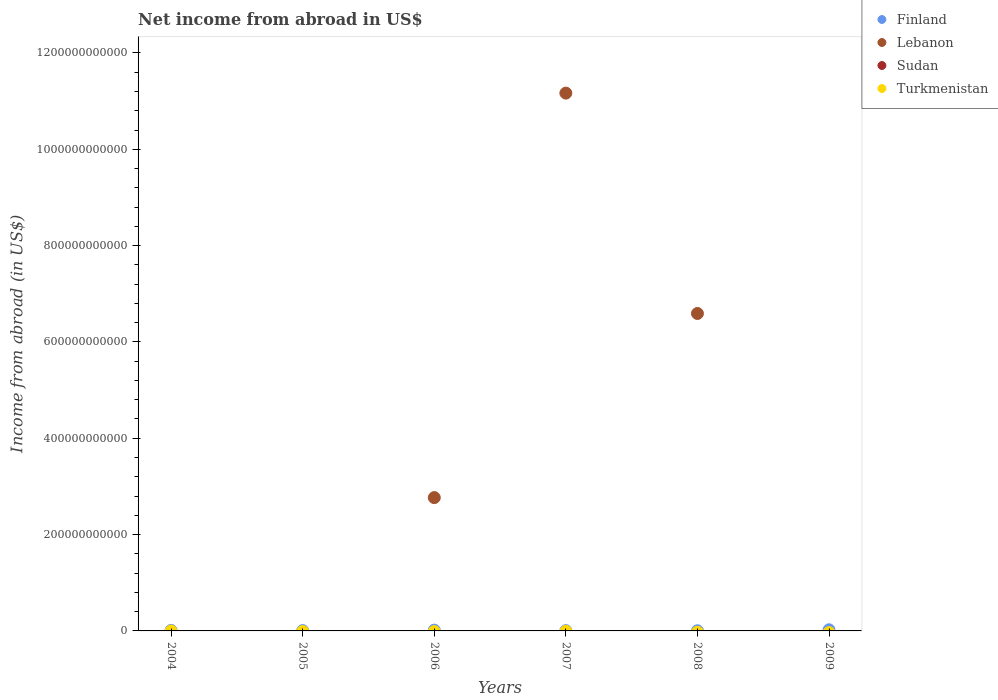Is the number of dotlines equal to the number of legend labels?
Give a very brief answer. No. What is the net income from abroad in Lebanon in 2007?
Offer a terse response. 1.12e+12. Across all years, what is the maximum net income from abroad in Lebanon?
Your answer should be very brief. 1.12e+12. What is the total net income from abroad in Finland in the graph?
Your answer should be compact. 6.70e+09. What is the difference between the net income from abroad in Finland in 2004 and that in 2007?
Offer a terse response. 5.26e+08. What is the average net income from abroad in Lebanon per year?
Ensure brevity in your answer.  3.42e+11. In how many years, is the net income from abroad in Turkmenistan greater than 400000000000 US$?
Provide a short and direct response. 0. Is the net income from abroad in Finland in 2004 less than that in 2007?
Your answer should be compact. No. What is the difference between the highest and the second highest net income from abroad in Lebanon?
Your answer should be very brief. 4.58e+11. What is the difference between the highest and the lowest net income from abroad in Lebanon?
Offer a very short reply. 1.12e+12. Is the sum of the net income from abroad in Finland in 2004 and 2005 greater than the maximum net income from abroad in Turkmenistan across all years?
Make the answer very short. Yes. Is it the case that in every year, the sum of the net income from abroad in Finland and net income from abroad in Sudan  is greater than the sum of net income from abroad in Lebanon and net income from abroad in Turkmenistan?
Your response must be concise. Yes. Is it the case that in every year, the sum of the net income from abroad in Finland and net income from abroad in Sudan  is greater than the net income from abroad in Lebanon?
Your answer should be compact. No. Does the net income from abroad in Finland monotonically increase over the years?
Make the answer very short. No. What is the difference between two consecutive major ticks on the Y-axis?
Offer a very short reply. 2.00e+11. Are the values on the major ticks of Y-axis written in scientific E-notation?
Your answer should be very brief. No. What is the title of the graph?
Give a very brief answer. Net income from abroad in US$. What is the label or title of the Y-axis?
Provide a short and direct response. Income from abroad (in US$). What is the Income from abroad (in US$) of Finland in 2004?
Keep it short and to the point. 1.12e+09. What is the Income from abroad (in US$) in Turkmenistan in 2004?
Your answer should be compact. 0. What is the Income from abroad (in US$) in Finland in 2005?
Offer a very short reply. 6.88e+08. What is the Income from abroad (in US$) of Lebanon in 2005?
Provide a short and direct response. 0. What is the Income from abroad (in US$) of Sudan in 2005?
Provide a succinct answer. 0. What is the Income from abroad (in US$) in Finland in 2006?
Offer a very short reply. 1.62e+09. What is the Income from abroad (in US$) of Lebanon in 2006?
Provide a succinct answer. 2.77e+11. What is the Income from abroad (in US$) of Turkmenistan in 2006?
Make the answer very short. 0. What is the Income from abroad (in US$) of Finland in 2007?
Your response must be concise. 5.89e+08. What is the Income from abroad (in US$) in Lebanon in 2007?
Offer a terse response. 1.12e+12. What is the Income from abroad (in US$) of Turkmenistan in 2007?
Provide a succinct answer. 0. What is the Income from abroad (in US$) in Finland in 2008?
Ensure brevity in your answer.  3.62e+08. What is the Income from abroad (in US$) of Lebanon in 2008?
Your response must be concise. 6.59e+11. What is the Income from abroad (in US$) of Turkmenistan in 2008?
Your answer should be very brief. 0. What is the Income from abroad (in US$) of Finland in 2009?
Offer a very short reply. 2.32e+09. Across all years, what is the maximum Income from abroad (in US$) of Finland?
Provide a succinct answer. 2.32e+09. Across all years, what is the maximum Income from abroad (in US$) of Lebanon?
Your response must be concise. 1.12e+12. Across all years, what is the minimum Income from abroad (in US$) of Finland?
Make the answer very short. 3.62e+08. What is the total Income from abroad (in US$) in Finland in the graph?
Your response must be concise. 6.70e+09. What is the total Income from abroad (in US$) of Lebanon in the graph?
Keep it short and to the point. 2.05e+12. What is the total Income from abroad (in US$) in Turkmenistan in the graph?
Keep it short and to the point. 0. What is the difference between the Income from abroad (in US$) of Finland in 2004 and that in 2005?
Provide a short and direct response. 4.27e+08. What is the difference between the Income from abroad (in US$) of Finland in 2004 and that in 2006?
Provide a succinct answer. -5.09e+08. What is the difference between the Income from abroad (in US$) in Finland in 2004 and that in 2007?
Your answer should be very brief. 5.26e+08. What is the difference between the Income from abroad (in US$) of Finland in 2004 and that in 2008?
Make the answer very short. 7.53e+08. What is the difference between the Income from abroad (in US$) in Finland in 2004 and that in 2009?
Your answer should be compact. -1.21e+09. What is the difference between the Income from abroad (in US$) in Finland in 2005 and that in 2006?
Make the answer very short. -9.36e+08. What is the difference between the Income from abroad (in US$) in Finland in 2005 and that in 2007?
Offer a terse response. 9.90e+07. What is the difference between the Income from abroad (in US$) in Finland in 2005 and that in 2008?
Give a very brief answer. 3.26e+08. What is the difference between the Income from abroad (in US$) of Finland in 2005 and that in 2009?
Your answer should be compact. -1.63e+09. What is the difference between the Income from abroad (in US$) of Finland in 2006 and that in 2007?
Provide a short and direct response. 1.04e+09. What is the difference between the Income from abroad (in US$) of Lebanon in 2006 and that in 2007?
Provide a succinct answer. -8.40e+11. What is the difference between the Income from abroad (in US$) in Finland in 2006 and that in 2008?
Offer a terse response. 1.26e+09. What is the difference between the Income from abroad (in US$) in Lebanon in 2006 and that in 2008?
Give a very brief answer. -3.82e+11. What is the difference between the Income from abroad (in US$) in Finland in 2006 and that in 2009?
Keep it short and to the point. -6.97e+08. What is the difference between the Income from abroad (in US$) in Finland in 2007 and that in 2008?
Ensure brevity in your answer.  2.27e+08. What is the difference between the Income from abroad (in US$) in Lebanon in 2007 and that in 2008?
Give a very brief answer. 4.58e+11. What is the difference between the Income from abroad (in US$) of Finland in 2007 and that in 2009?
Offer a terse response. -1.73e+09. What is the difference between the Income from abroad (in US$) of Finland in 2008 and that in 2009?
Provide a succinct answer. -1.96e+09. What is the difference between the Income from abroad (in US$) in Finland in 2004 and the Income from abroad (in US$) in Lebanon in 2006?
Provide a short and direct response. -2.76e+11. What is the difference between the Income from abroad (in US$) of Finland in 2004 and the Income from abroad (in US$) of Lebanon in 2007?
Offer a terse response. -1.12e+12. What is the difference between the Income from abroad (in US$) of Finland in 2004 and the Income from abroad (in US$) of Lebanon in 2008?
Provide a short and direct response. -6.58e+11. What is the difference between the Income from abroad (in US$) of Finland in 2005 and the Income from abroad (in US$) of Lebanon in 2006?
Ensure brevity in your answer.  -2.76e+11. What is the difference between the Income from abroad (in US$) of Finland in 2005 and the Income from abroad (in US$) of Lebanon in 2007?
Keep it short and to the point. -1.12e+12. What is the difference between the Income from abroad (in US$) in Finland in 2005 and the Income from abroad (in US$) in Lebanon in 2008?
Provide a short and direct response. -6.58e+11. What is the difference between the Income from abroad (in US$) in Finland in 2006 and the Income from abroad (in US$) in Lebanon in 2007?
Provide a succinct answer. -1.11e+12. What is the difference between the Income from abroad (in US$) in Finland in 2006 and the Income from abroad (in US$) in Lebanon in 2008?
Your answer should be compact. -6.57e+11. What is the difference between the Income from abroad (in US$) of Finland in 2007 and the Income from abroad (in US$) of Lebanon in 2008?
Offer a terse response. -6.58e+11. What is the average Income from abroad (in US$) of Finland per year?
Keep it short and to the point. 1.12e+09. What is the average Income from abroad (in US$) of Lebanon per year?
Your answer should be compact. 3.42e+11. What is the average Income from abroad (in US$) of Sudan per year?
Make the answer very short. 0. What is the average Income from abroad (in US$) in Turkmenistan per year?
Make the answer very short. 0. In the year 2006, what is the difference between the Income from abroad (in US$) in Finland and Income from abroad (in US$) in Lebanon?
Provide a succinct answer. -2.75e+11. In the year 2007, what is the difference between the Income from abroad (in US$) in Finland and Income from abroad (in US$) in Lebanon?
Offer a very short reply. -1.12e+12. In the year 2008, what is the difference between the Income from abroad (in US$) in Finland and Income from abroad (in US$) in Lebanon?
Your response must be concise. -6.59e+11. What is the ratio of the Income from abroad (in US$) in Finland in 2004 to that in 2005?
Ensure brevity in your answer.  1.62. What is the ratio of the Income from abroad (in US$) in Finland in 2004 to that in 2006?
Your answer should be compact. 0.69. What is the ratio of the Income from abroad (in US$) of Finland in 2004 to that in 2007?
Offer a terse response. 1.89. What is the ratio of the Income from abroad (in US$) in Finland in 2004 to that in 2008?
Give a very brief answer. 3.08. What is the ratio of the Income from abroad (in US$) of Finland in 2004 to that in 2009?
Give a very brief answer. 0.48. What is the ratio of the Income from abroad (in US$) in Finland in 2005 to that in 2006?
Keep it short and to the point. 0.42. What is the ratio of the Income from abroad (in US$) in Finland in 2005 to that in 2007?
Provide a succinct answer. 1.17. What is the ratio of the Income from abroad (in US$) of Finland in 2005 to that in 2008?
Ensure brevity in your answer.  1.9. What is the ratio of the Income from abroad (in US$) of Finland in 2005 to that in 2009?
Provide a succinct answer. 0.3. What is the ratio of the Income from abroad (in US$) in Finland in 2006 to that in 2007?
Your response must be concise. 2.76. What is the ratio of the Income from abroad (in US$) of Lebanon in 2006 to that in 2007?
Your answer should be very brief. 0.25. What is the ratio of the Income from abroad (in US$) in Finland in 2006 to that in 2008?
Make the answer very short. 4.49. What is the ratio of the Income from abroad (in US$) in Lebanon in 2006 to that in 2008?
Provide a short and direct response. 0.42. What is the ratio of the Income from abroad (in US$) of Finland in 2006 to that in 2009?
Keep it short and to the point. 0.7. What is the ratio of the Income from abroad (in US$) of Finland in 2007 to that in 2008?
Offer a very short reply. 1.63. What is the ratio of the Income from abroad (in US$) in Lebanon in 2007 to that in 2008?
Offer a terse response. 1.69. What is the ratio of the Income from abroad (in US$) in Finland in 2007 to that in 2009?
Offer a very short reply. 0.25. What is the ratio of the Income from abroad (in US$) of Finland in 2008 to that in 2009?
Your answer should be compact. 0.16. What is the difference between the highest and the second highest Income from abroad (in US$) in Finland?
Keep it short and to the point. 6.97e+08. What is the difference between the highest and the second highest Income from abroad (in US$) of Lebanon?
Provide a short and direct response. 4.58e+11. What is the difference between the highest and the lowest Income from abroad (in US$) in Finland?
Offer a terse response. 1.96e+09. What is the difference between the highest and the lowest Income from abroad (in US$) in Lebanon?
Provide a short and direct response. 1.12e+12. 